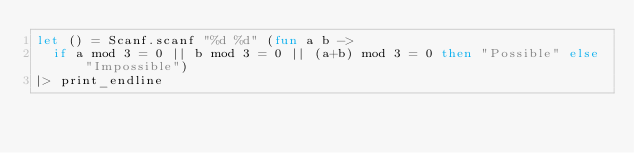<code> <loc_0><loc_0><loc_500><loc_500><_OCaml_>let () = Scanf.scanf "%d %d" (fun a b ->
  if a mod 3 = 0 || b mod 3 = 0 || (a+b) mod 3 = 0 then "Possible" else "Impossible")
|> print_endline
</code> 